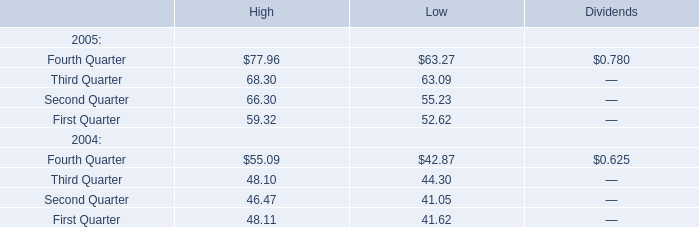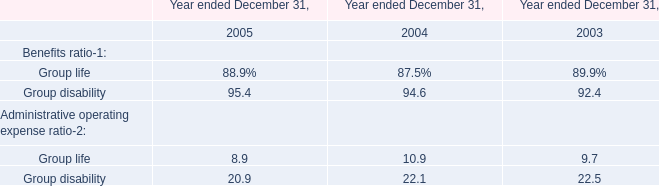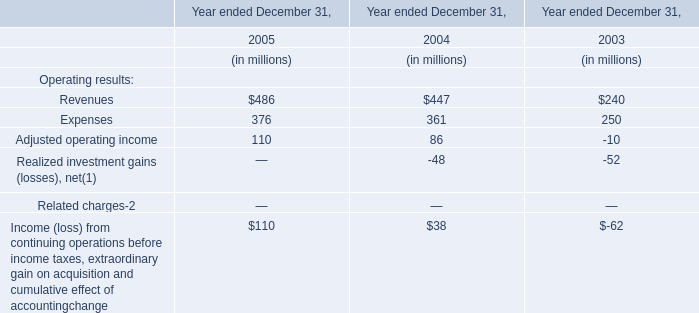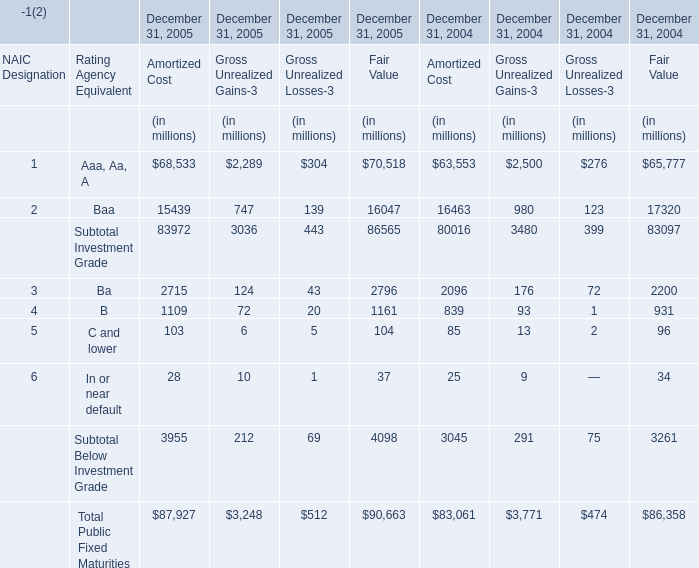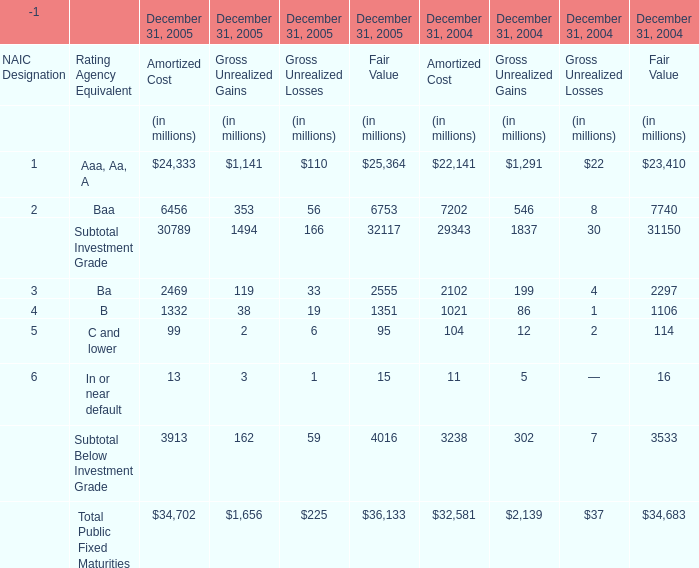What was the total amount of elements for Amortized Cost greater than 6000 in 2005? (in million) 
Computations: (24333 + 6456)
Answer: 30789.0. 